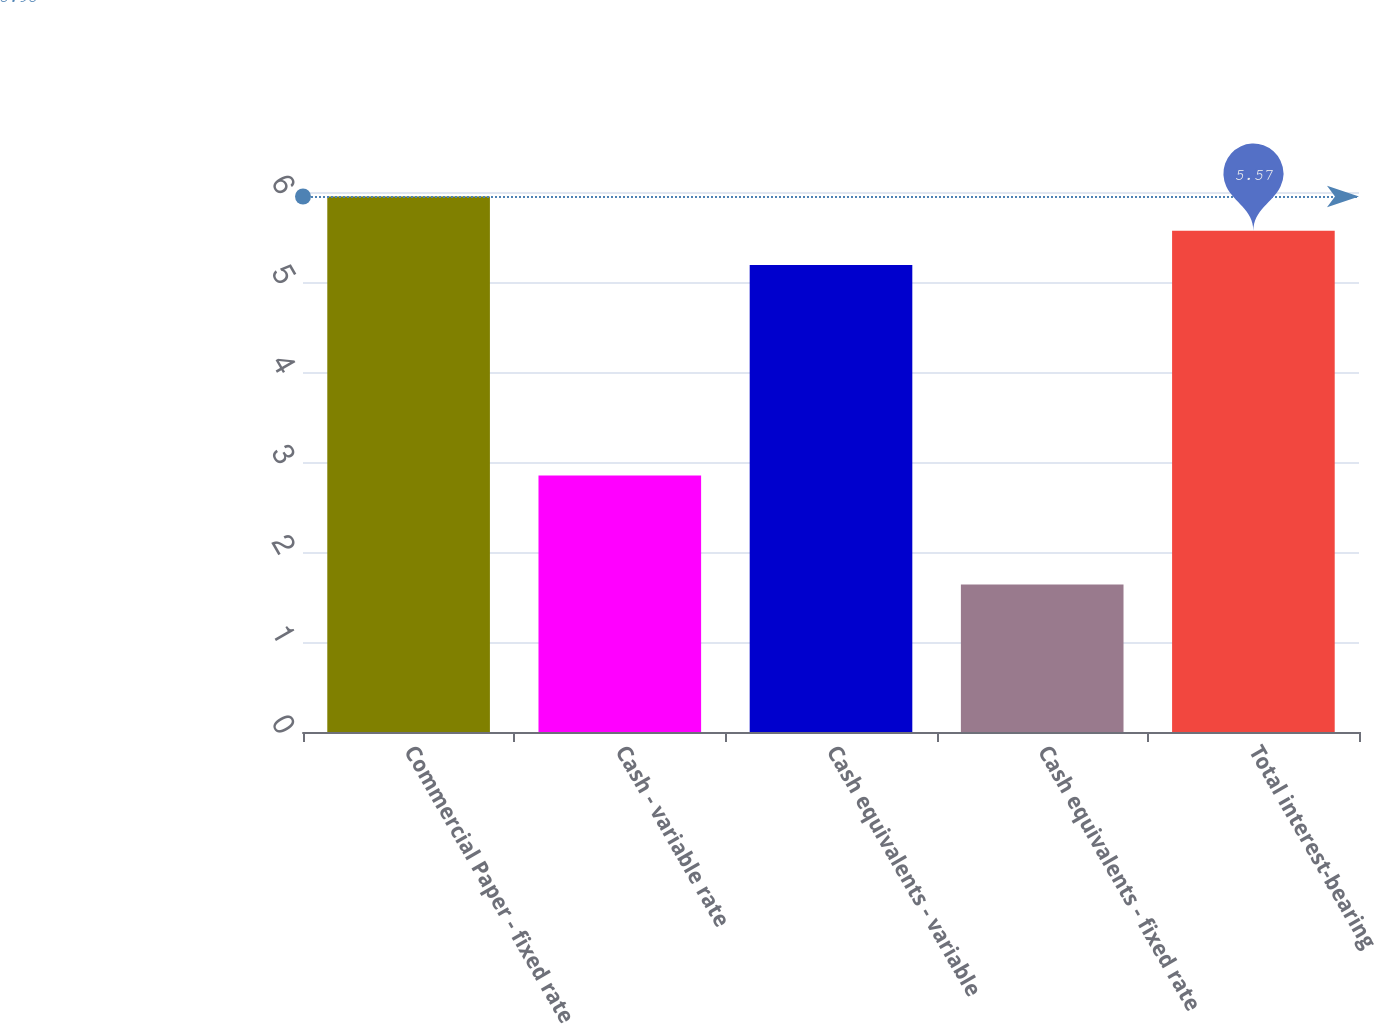<chart> <loc_0><loc_0><loc_500><loc_500><bar_chart><fcel>Commercial Paper - fixed rate<fcel>Cash - variable rate<fcel>Cash equivalents - variable<fcel>Cash equivalents - fixed rate<fcel>Total interest-bearing<nl><fcel>5.95<fcel>2.85<fcel>5.19<fcel>1.64<fcel>5.57<nl></chart> 